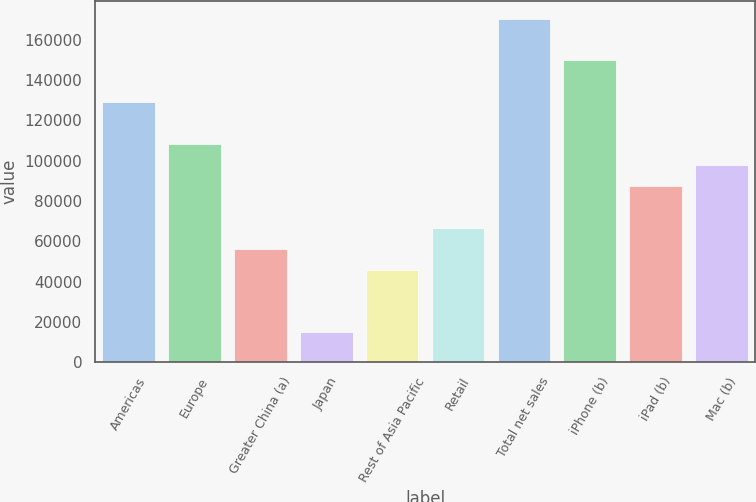<chart> <loc_0><loc_0><loc_500><loc_500><bar_chart><fcel>Americas<fcel>Europe<fcel>Greater China (a)<fcel>Japan<fcel>Rest of Asia Pacific<fcel>Retail<fcel>Total net sales<fcel>iPhone (b)<fcel>iPad (b)<fcel>Mac (b)<nl><fcel>129004<fcel>108249<fcel>56361.5<fcel>14851.5<fcel>45984<fcel>66739<fcel>170514<fcel>149759<fcel>87494<fcel>97871.5<nl></chart> 